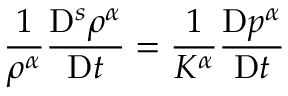<formula> <loc_0><loc_0><loc_500><loc_500>\frac { 1 } { \rho ^ { \alpha } } \frac { D ^ { s } \rho ^ { \alpha } } { D t } = \frac { 1 } { K ^ { \alpha } } \frac { D p ^ { \alpha } } { D t }</formula> 